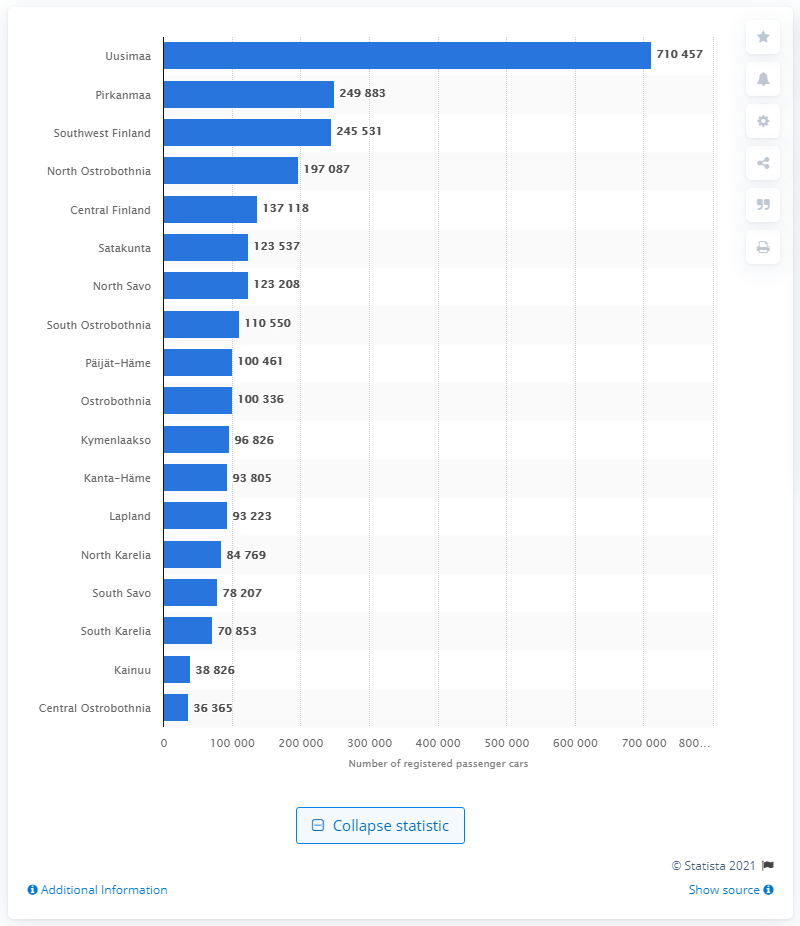Draw attention to some important aspects in this diagram. In the south of Finland, Uusimaa had the largest amount of registered passenger cars. 